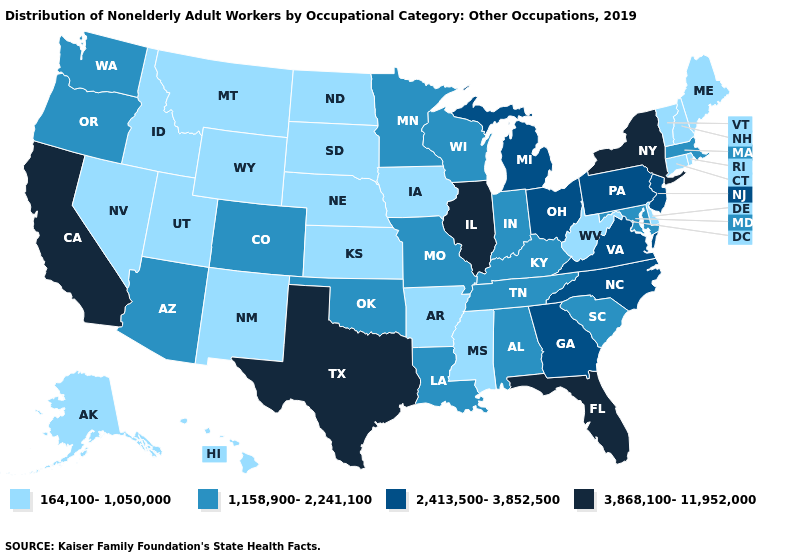What is the lowest value in the West?
Concise answer only. 164,100-1,050,000. What is the lowest value in states that border Arizona?
Quick response, please. 164,100-1,050,000. Name the states that have a value in the range 1,158,900-2,241,100?
Answer briefly. Alabama, Arizona, Colorado, Indiana, Kentucky, Louisiana, Maryland, Massachusetts, Minnesota, Missouri, Oklahoma, Oregon, South Carolina, Tennessee, Washington, Wisconsin. Is the legend a continuous bar?
Quick response, please. No. Does New York have the highest value in the Northeast?
Quick response, please. Yes. Which states have the highest value in the USA?
Give a very brief answer. California, Florida, Illinois, New York, Texas. What is the value of Hawaii?
Concise answer only. 164,100-1,050,000. Name the states that have a value in the range 164,100-1,050,000?
Answer briefly. Alaska, Arkansas, Connecticut, Delaware, Hawaii, Idaho, Iowa, Kansas, Maine, Mississippi, Montana, Nebraska, Nevada, New Hampshire, New Mexico, North Dakota, Rhode Island, South Dakota, Utah, Vermont, West Virginia, Wyoming. Does Washington have the lowest value in the West?
Give a very brief answer. No. Name the states that have a value in the range 164,100-1,050,000?
Keep it brief. Alaska, Arkansas, Connecticut, Delaware, Hawaii, Idaho, Iowa, Kansas, Maine, Mississippi, Montana, Nebraska, Nevada, New Hampshire, New Mexico, North Dakota, Rhode Island, South Dakota, Utah, Vermont, West Virginia, Wyoming. Name the states that have a value in the range 2,413,500-3,852,500?
Quick response, please. Georgia, Michigan, New Jersey, North Carolina, Ohio, Pennsylvania, Virginia. Name the states that have a value in the range 164,100-1,050,000?
Be succinct. Alaska, Arkansas, Connecticut, Delaware, Hawaii, Idaho, Iowa, Kansas, Maine, Mississippi, Montana, Nebraska, Nevada, New Hampshire, New Mexico, North Dakota, Rhode Island, South Dakota, Utah, Vermont, West Virginia, Wyoming. Does Rhode Island have the same value as Maryland?
Answer briefly. No. Name the states that have a value in the range 2,413,500-3,852,500?
Answer briefly. Georgia, Michigan, New Jersey, North Carolina, Ohio, Pennsylvania, Virginia. Name the states that have a value in the range 3,868,100-11,952,000?
Be succinct. California, Florida, Illinois, New York, Texas. 